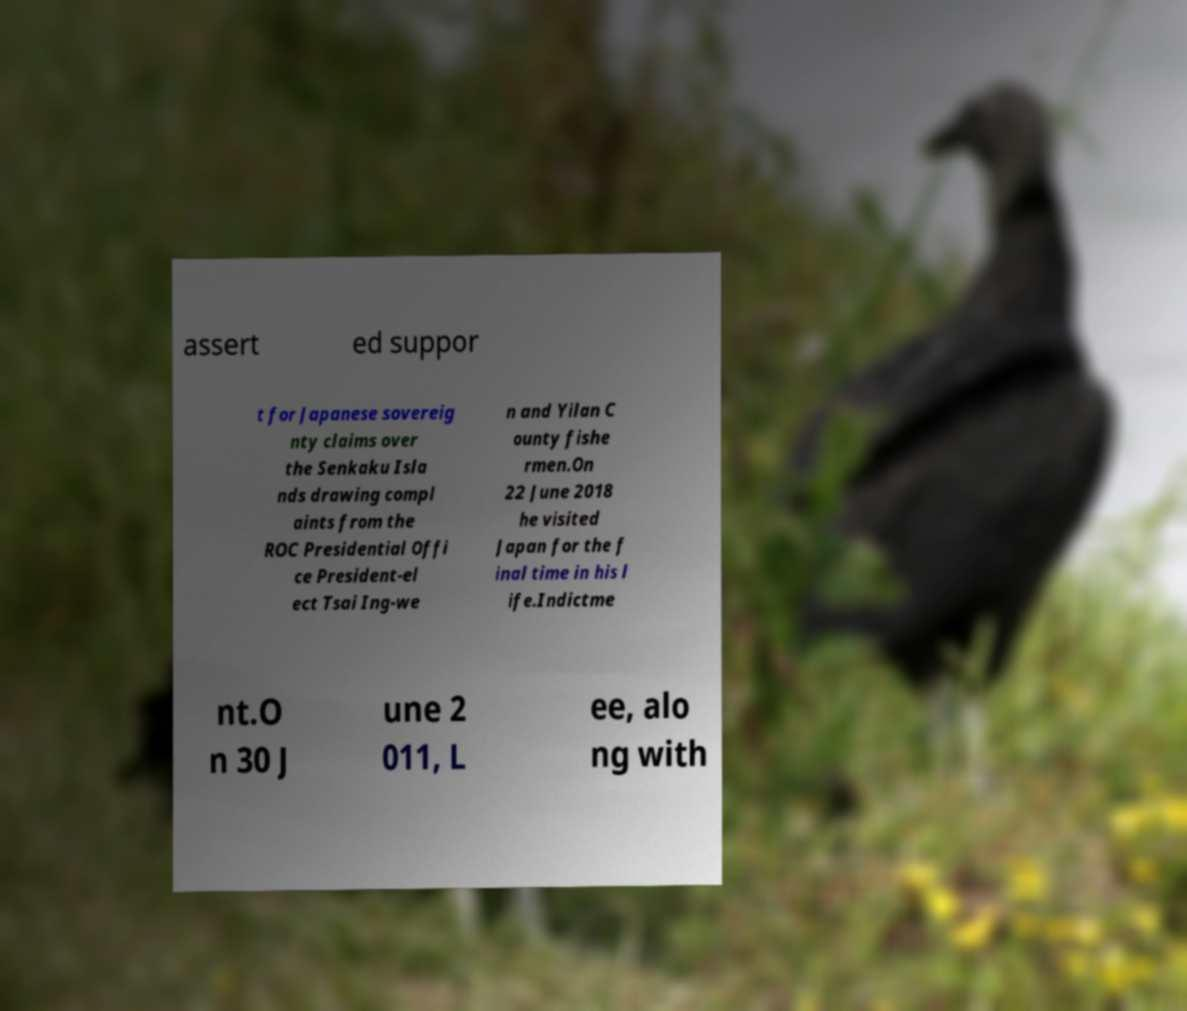There's text embedded in this image that I need extracted. Can you transcribe it verbatim? assert ed suppor t for Japanese sovereig nty claims over the Senkaku Isla nds drawing compl aints from the ROC Presidential Offi ce President-el ect Tsai Ing-we n and Yilan C ounty fishe rmen.On 22 June 2018 he visited Japan for the f inal time in his l ife.Indictme nt.O n 30 J une 2 011, L ee, alo ng with 